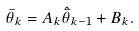<formula> <loc_0><loc_0><loc_500><loc_500>\bar { \theta } _ { k } = A _ { k } \hat { \bar { \theta } } _ { k - 1 } + B _ { k } .</formula> 